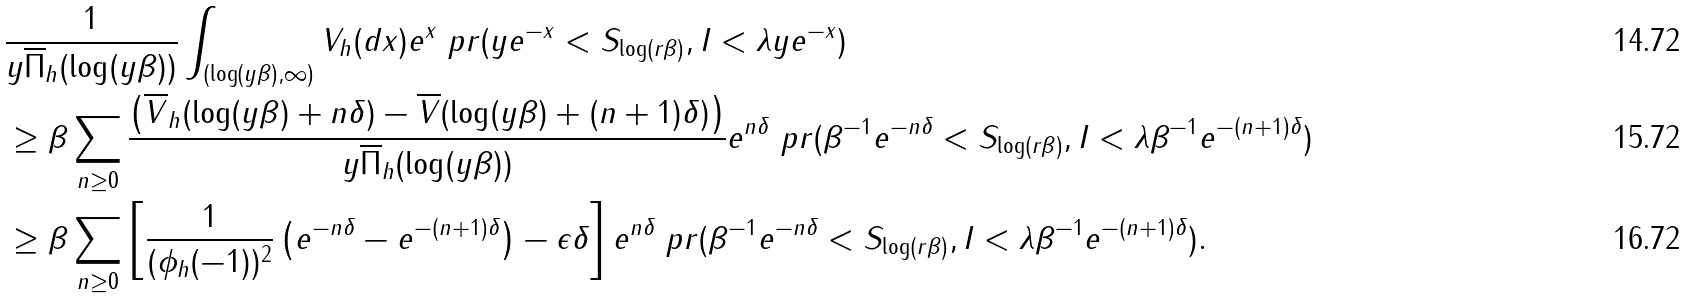<formula> <loc_0><loc_0><loc_500><loc_500>& \frac { 1 } { y \overline { \Pi } _ { h } ( \log ( y \beta ) ) } \int _ { ( \log ( y \beta ) , \infty ) } V _ { h } ( d x ) e ^ { x } \ p r ( y e ^ { - x } < S _ { \log ( r \beta ) } , I < \lambda y e ^ { - x } ) \\ & \geq \beta \sum _ { n \geq 0 } \frac { \left ( \overline { V } _ { h } ( \log ( y \beta ) + n \delta ) - \overline { V } ( { \log ( y \beta ) + ( n + 1 ) \delta } ) \right ) } { y \overline { \Pi } _ { h } ( \log ( y \beta ) ) } e ^ { n \delta } \ p r ( \beta ^ { - 1 } e ^ { - n \delta } < S _ { \log ( r \beta ) } , I < \lambda \beta ^ { - 1 } e ^ { - ( n + 1 ) \delta } ) \\ & \geq \beta \sum _ { n \geq 0 } \left [ \frac { 1 } { ( \phi _ { h } ( - 1 ) ) ^ { 2 } } \left ( e ^ { - n \delta } - e ^ { - ( n + 1 ) \delta } \right ) - \epsilon \delta \right ] e ^ { n \delta } \ p r ( \beta ^ { - 1 } e ^ { - n \delta } < S _ { \log ( r \beta ) } , I < \lambda \beta ^ { - 1 } e ^ { - ( n + 1 ) \delta } ) .</formula> 